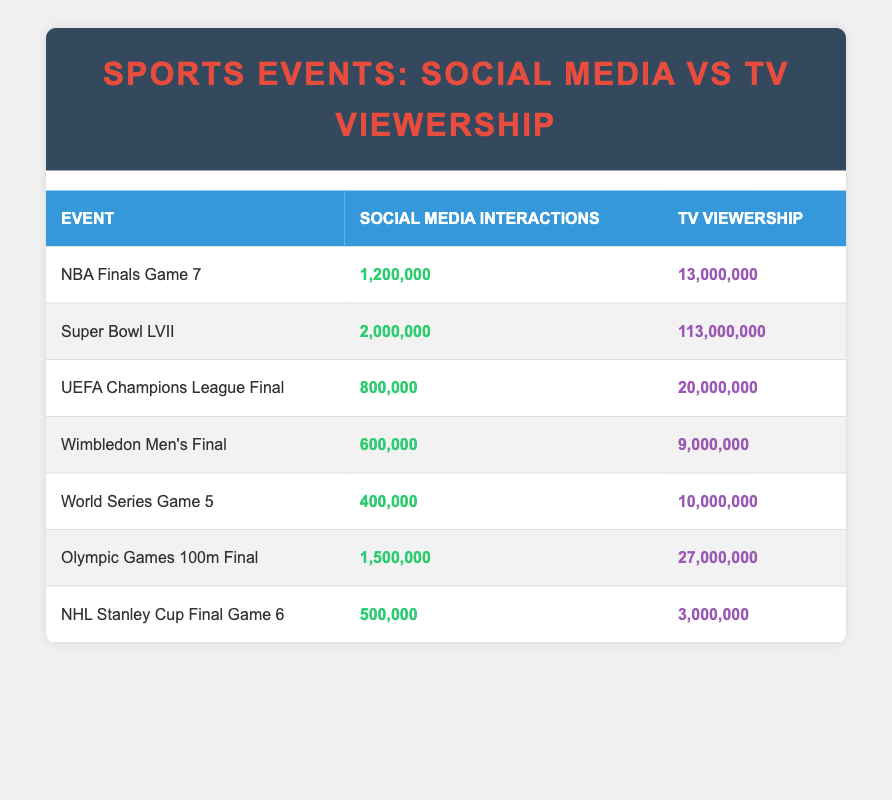What is the highest TV viewership among the events listed? The table shows the TV viewership for each event. "Super Bowl LVII" has the highest number with 113,000,000 viewers.
Answer: 113,000,000 Which event had more social media interactions, the "NBA Finals Game 7" or the "Olympic Games 100m Final"? The "NBA Finals Game 7" had 1,200,000 interactions, while the "Olympic Games 100m Final" had 1,500,000 interactions. Therefore, the "Olympic Games 100m Final" had more interactions.
Answer: Olympic Games 100m Final What is the total social media interactions for the three most interacted events? First, we identify the three events with the highest social media interactions: "Super Bowl LVII" (2,000,000), "Olympic Games 100m Final" (1,500,000), and "NBA Finals Game 7" (1,200,000). The total is 2,000,000 + 1,500,000 + 1,200,000 = 4,700,000.
Answer: 4,700,000 Is the TV viewership for the "World Series Game 5" more than the viewership for the "Wimbledon Men’s Final"? The "World Series Game 5" has 10,000,000 viewers, while the "Wimbledon Men’s Final" has 9,000,000 viewers. Since 10,000,000 is greater than 9,000,000, the statement is true.
Answer: Yes What is the average social media interaction across all events in the table? There are seven events: 1,200,000 + 2,000,000 + 800,000 + 600,000 + 400,000 + 1,500,000 + 500,000 = 6,100,000. To find the average, we divide by 7, which gives us approximately 871,429.
Answer: 871,429 Which event has the least social media interactions? Checking the interactions column, "NHL Stanley Cup Final Game 6" has the lowest number with 500,000 interactions.
Answer: NHL Stanley Cup Final Game 6 If we add the TV viewership of "NBA Finals Game 7" and "NHL Stanley Cup Final Game 6", how does it compare to "Wimbledon Men’s Final"? "NBA Finals Game 7" has 13,000,000 viewers and "NHL Stanley Cup Final Game 6" has 3,000,000 viewers, totaling 16,000,000. The "Wimbledon Men’s Final" has 9,000,000 viewers. Since 16,000,000 is greater than 9,000,000, the total exceeds the viewership of the Wimbledon event.
Answer: Exceeds What percentage of total social media interactions does the "Super Bowl LVII" represent? First, sum all social media interactions: 6,100,000. The "Super Bowl LVII" interactions are 2,000,000. To find the percentage, we use (2,000,000 / 6,100,000) * 100 ≈ 32.79%.
Answer: 32.79% 